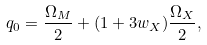Convert formula to latex. <formula><loc_0><loc_0><loc_500><loc_500>q _ { 0 } = { \frac { \Omega _ { M } } { 2 } } + ( 1 + 3 w _ { X } ) { \frac { \Omega _ { X } } { 2 } } ,</formula> 